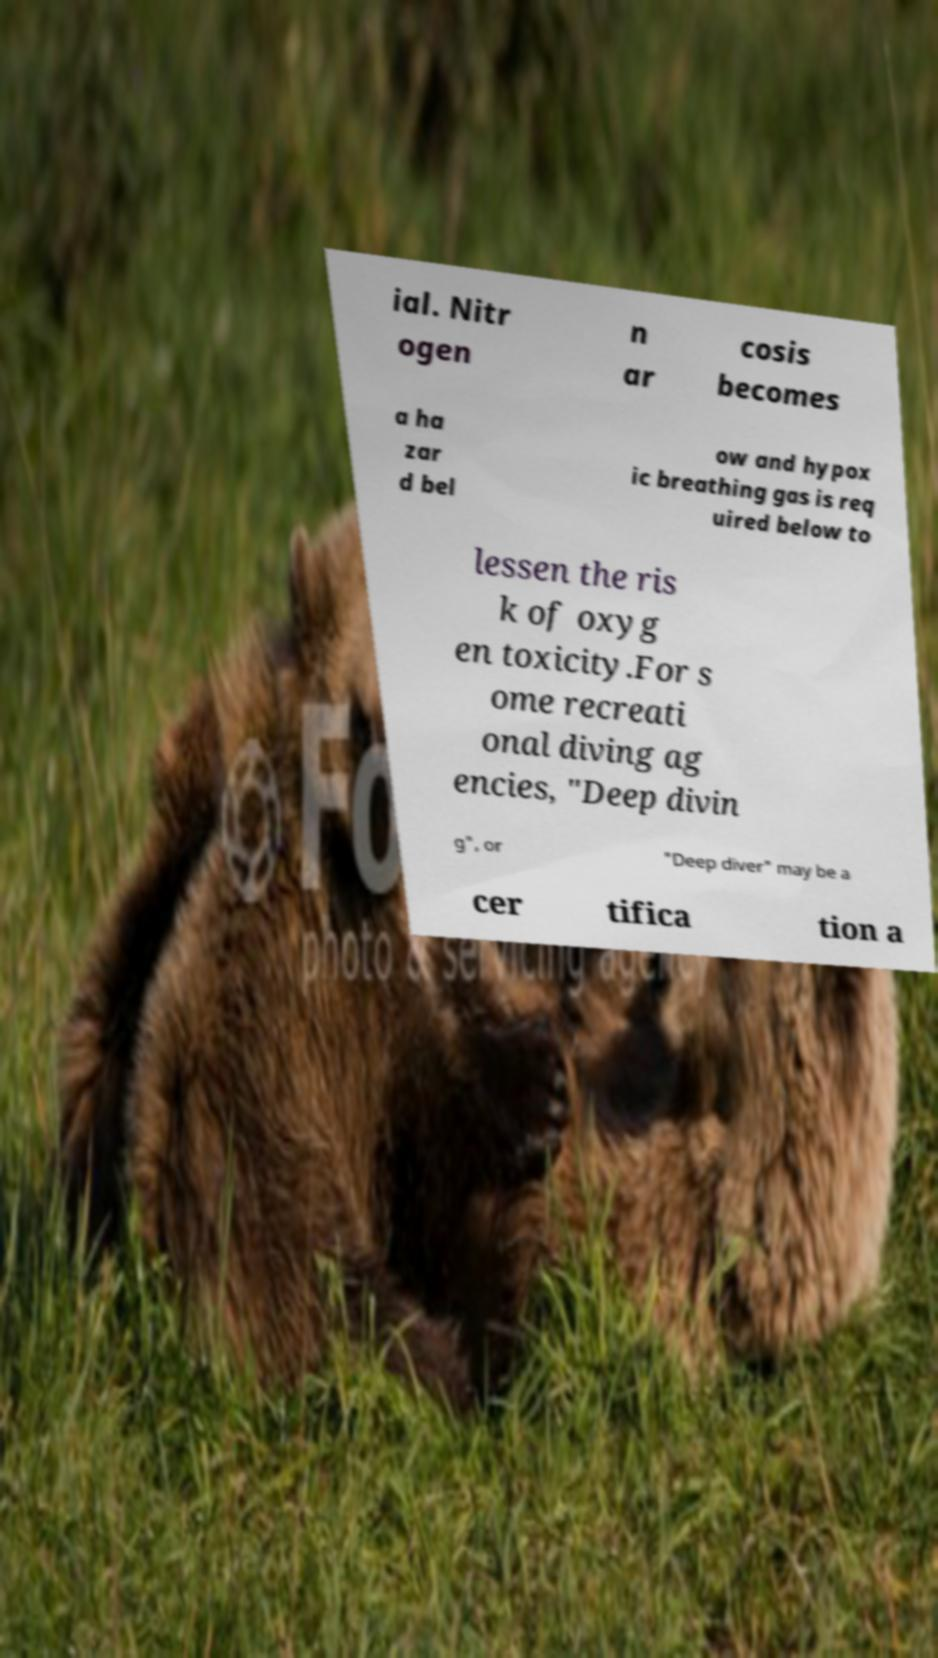For documentation purposes, I need the text within this image transcribed. Could you provide that? ial. Nitr ogen n ar cosis becomes a ha zar d bel ow and hypox ic breathing gas is req uired below to lessen the ris k of oxyg en toxicity.For s ome recreati onal diving ag encies, "Deep divin g", or "Deep diver" may be a cer tifica tion a 